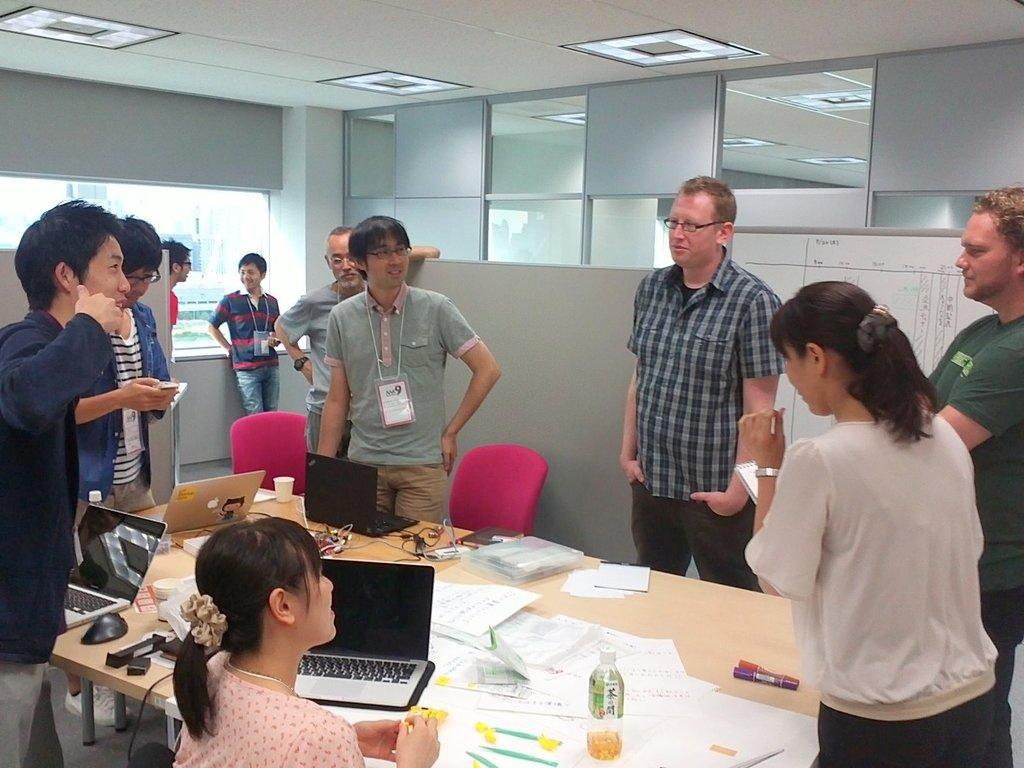Can you describe this image briefly? In the center of the image we can see a table. On the table we can see the laptops, papers, bottle, pens, markers, glasses and some other objects. Beside the table we can see some people are standing. On the right side of the image we can see a lady is standing and holding a paper. At the bottom of the image we can see a lady is sitting. In the background of the image we can see the chairs, floor, wall, board, glass, window. On the board we can see the text. At the top of the image we can see the roof and lights. 